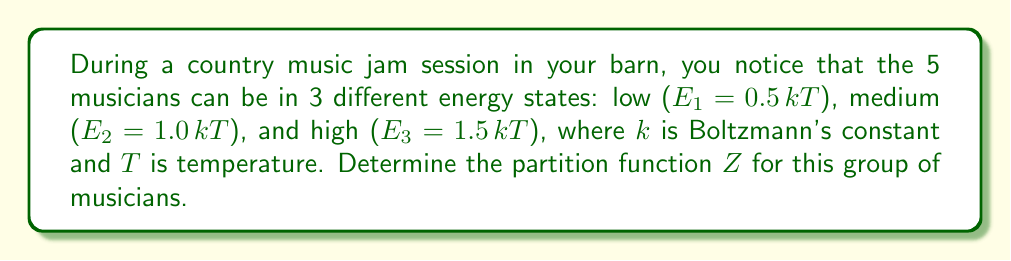What is the answer to this math problem? To solve this problem, we'll follow these steps:

1) Recall that the partition function Z for a system with discrete energy levels is given by:

   $$Z = \sum_i g_i e^{-E_i/kT}$$

   where $g_i$ is the degeneracy of energy level $E_i$.

2) In this case, we have three energy levels:
   $E_1 = 0.5 kT$
   $E_2 = 1.0 kT$
   $E_3 = 1.5 kT$

3) Each musician can be in any of these states, so the degeneracy for each level is 1.

4) Let's calculate the Boltzmann factor for each energy level:
   
   For $E_1$: $e^{-E_1/kT} = e^{-0.5} = 0.6065$
   For $E_2$: $e^{-E_2/kT} = e^{-1.0} = 0.3679$
   For $E_3$: $e^{-E_3/kT} = e^{-1.5} = 0.2231$

5) The partition function for a single musician is:

   $$Z_1 = e^{-0.5} + e^{-1.0} + e^{-1.5} = 0.6065 + 0.3679 + 0.2231 = 1.1975$$

6) Since there are 5 independent musicians, and each can be in any state regardless of the others, the total partition function is:

   $$Z = (Z_1)^5 = (1.1975)^5 = 2.4843$$
Answer: $Z = 2.4843$ 